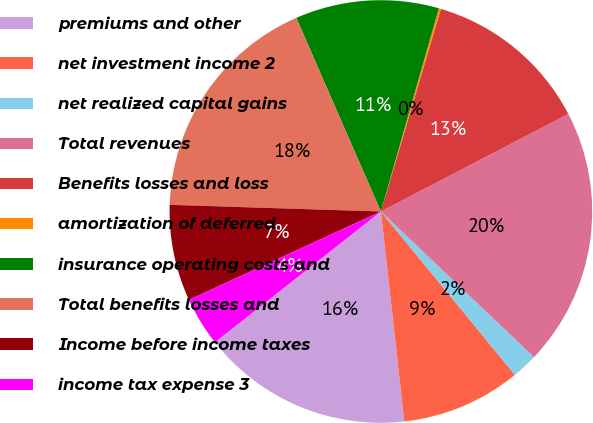Convert chart. <chart><loc_0><loc_0><loc_500><loc_500><pie_chart><fcel>premiums and other<fcel>net investment income 2<fcel>net realized capital gains<fcel>Total revenues<fcel>Benefits losses and loss<fcel>amortization of deferred<fcel>insurance operating costs and<fcel>Total benefits losses and<fcel>Income before income taxes<fcel>income tax expense 3<nl><fcel>16.14%<fcel>9.17%<fcel>1.96%<fcel>19.74%<fcel>12.78%<fcel>0.16%<fcel>10.98%<fcel>17.94%<fcel>7.37%<fcel>3.76%<nl></chart> 